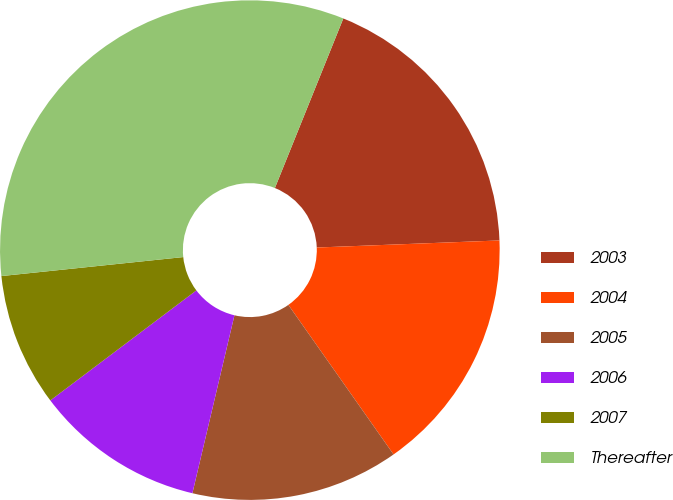<chart> <loc_0><loc_0><loc_500><loc_500><pie_chart><fcel>2003<fcel>2004<fcel>2005<fcel>2006<fcel>2007<fcel>Thereafter<nl><fcel>18.28%<fcel>15.86%<fcel>13.45%<fcel>11.03%<fcel>8.62%<fcel>32.76%<nl></chart> 